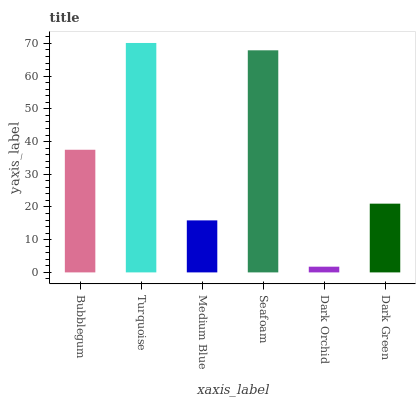Is Dark Orchid the minimum?
Answer yes or no. Yes. Is Turquoise the maximum?
Answer yes or no. Yes. Is Medium Blue the minimum?
Answer yes or no. No. Is Medium Blue the maximum?
Answer yes or no. No. Is Turquoise greater than Medium Blue?
Answer yes or no. Yes. Is Medium Blue less than Turquoise?
Answer yes or no. Yes. Is Medium Blue greater than Turquoise?
Answer yes or no. No. Is Turquoise less than Medium Blue?
Answer yes or no. No. Is Bubblegum the high median?
Answer yes or no. Yes. Is Dark Green the low median?
Answer yes or no. Yes. Is Dark Green the high median?
Answer yes or no. No. Is Bubblegum the low median?
Answer yes or no. No. 